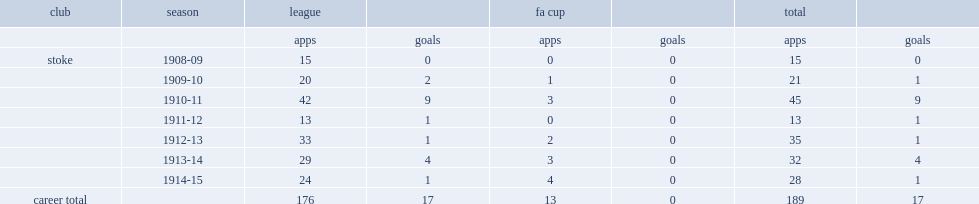What was the number of league appearances made by turner for stoke totally? 176.0. 